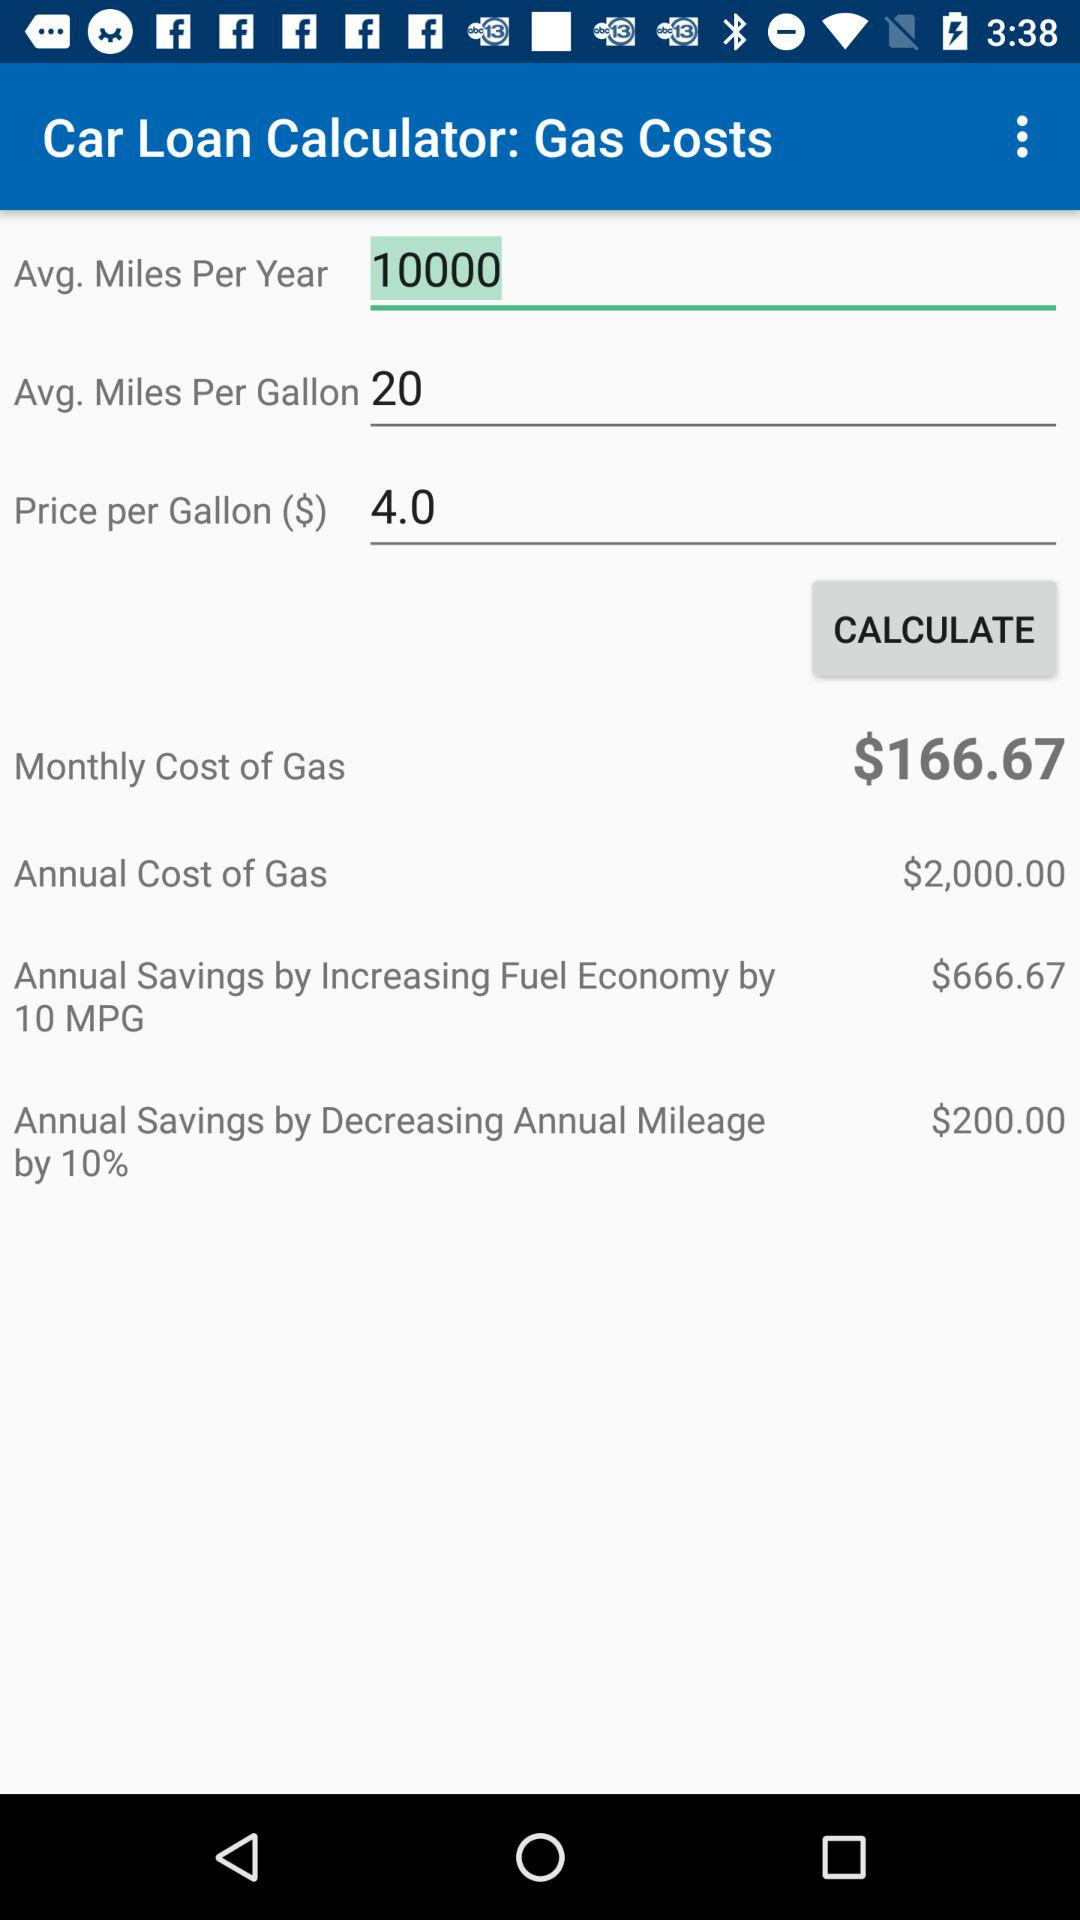How much will the annual savings be if annual mileage is reduced by 10%? The annual savings will be $200.00 if annual mileage is reduced by 10%. 